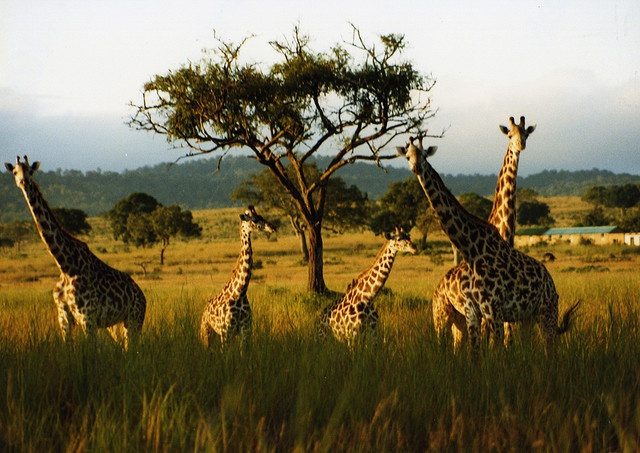Describe the objects in this image and their specific colors. I can see giraffe in white, black, olive, and maroon tones, giraffe in white, black, olive, and maroon tones, giraffe in white, black, olive, and maroon tones, giraffe in white, black, red, maroon, and orange tones, and giraffe in white, black, olive, and maroon tones in this image. 